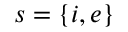<formula> <loc_0><loc_0><loc_500><loc_500>s = \{ i , e \}</formula> 